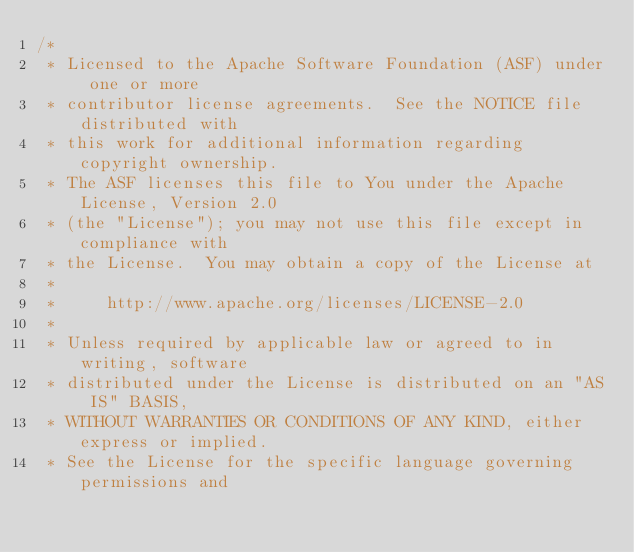Convert code to text. <code><loc_0><loc_0><loc_500><loc_500><_Java_>/*
 * Licensed to the Apache Software Foundation (ASF) under one or more
 * contributor license agreements.  See the NOTICE file distributed with
 * this work for additional information regarding copyright ownership.
 * The ASF licenses this file to You under the Apache License, Version 2.0
 * (the "License"); you may not use this file except in compliance with
 * the License.  You may obtain a copy of the License at
 *
 *     http://www.apache.org/licenses/LICENSE-2.0
 *
 * Unless required by applicable law or agreed to in writing, software
 * distributed under the License is distributed on an "AS IS" BASIS,
 * WITHOUT WARRANTIES OR CONDITIONS OF ANY KIND, either express or implied.
 * See the License for the specific language governing permissions and</code> 